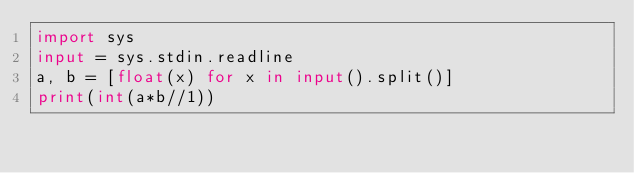<code> <loc_0><loc_0><loc_500><loc_500><_Python_>import sys
input = sys.stdin.readline
a, b = [float(x) for x in input().split()]
print(int(a*b//1))</code> 